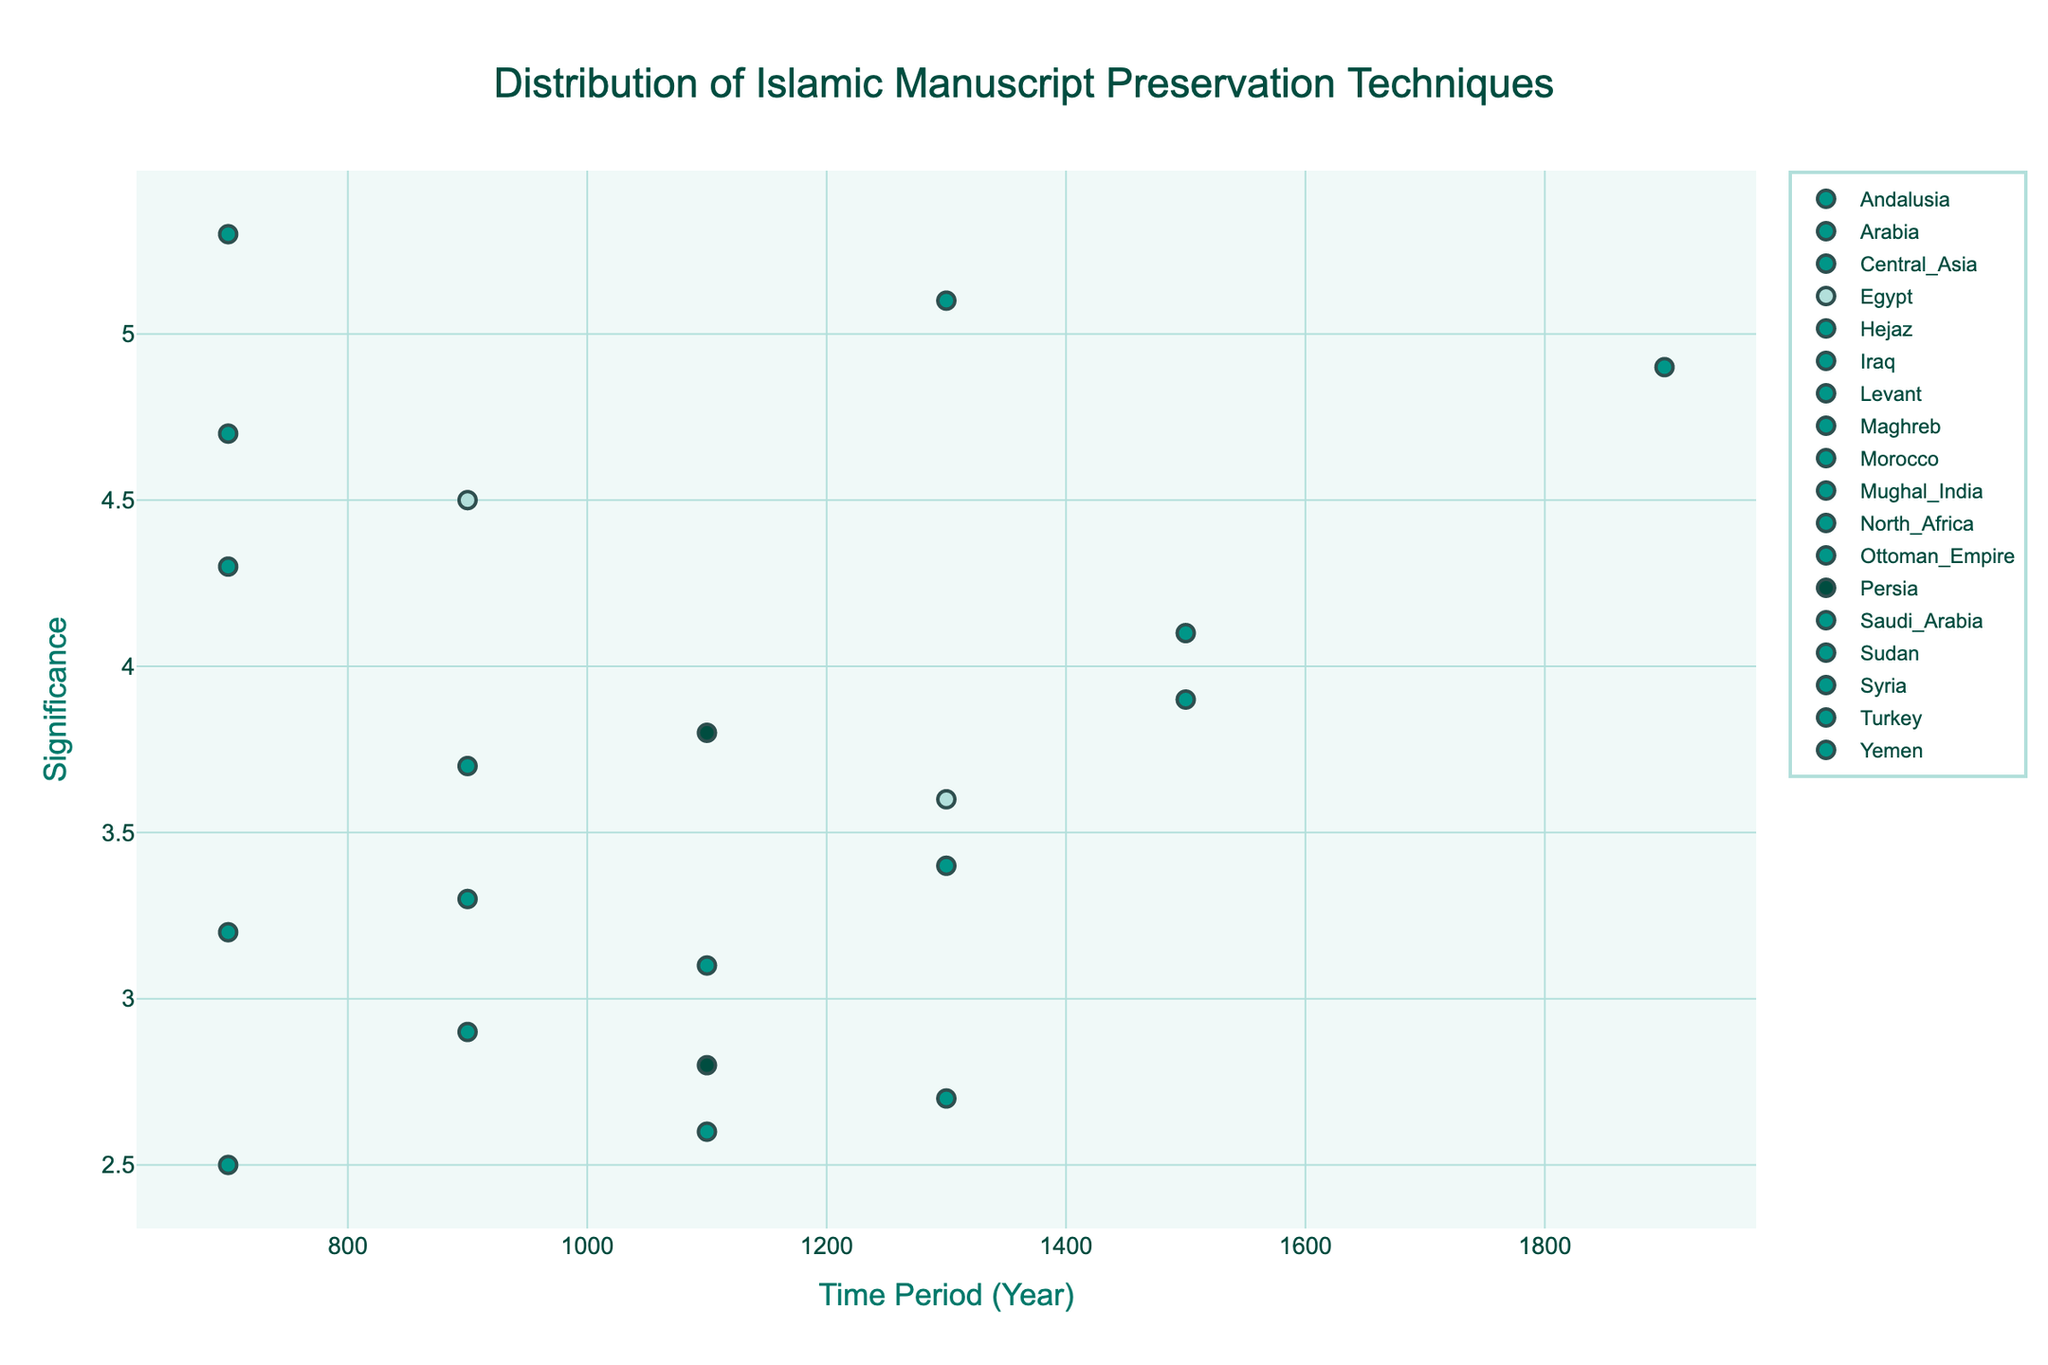What is the title of the plot? The title is prominently displayed at the top of the plot. It reads "Distribution of Islamic Manuscript Preservation Techniques" as indicated in the code.
Answer: Distribution of Islamic Manuscript Preservation Techniques What are the X and Y axes representing? The X-axis shows the "Time Period (Year)," indicating different eras from 700 to 2100, and the Y-axis shows "Significance," representing the significance level of the preservation technique. Both axes titles are specifically set in the code.
Answer: Time Period (Year), Significance How many regions are included in the plot? The plot includes different regions, each with its own markers. By counting the unique regions using the code, there are 15 regions represented.
Answer: 15 Which technique has the highest significance, and what is its value? By observing the highest point on the Y-axis, we can see that "Quranic Illumination" in Hejaz during 700-900 has the highest significance with a value of 5.3.
Answer: Quranic Illumination, 5.3 What is the significance of "Manuscript Digitization" in Saudi Arabia during the 1900-2100 period? By locating the data point for "Manuscript Digitization" in Saudi Arabia at the 1900-2100 period on the X-axis, we find its significance value at 4.9.
Answer: 4.9 Compare the significance of "Leather Binding" in the Maghreb region and "Paper Preservation" in Egypt. Which one is higher, and by how much? Check the significance values for both techniques: "Leather Binding" in Maghreb has a significance of 3.2, and "Paper Preservation" in Egypt has a significance of 4.5. Therefore, 4.5 - 3.2 gives a difference of 1.3.
Answer: Paper Preservation, 1.3 In which time period and region was the "Vellum Preparation" technique significant, and what was its significance value? By identifying the data point labeled 'Vellum Preparation,' it is significant in North Africa during the 1100-1300 period and has a significance value of 3.1 as per the data.
Answer: 1100-1300, North Africa, 3.1 Which technique has the lowest significance, and during which time period and region did it occur? The lowest point on the Y-axis corresponds to "Papyrus Conservation" in Sudan during the 700-900 period with a significance value of 2.5.
Answer: Papyrus Conservation, 700-900, Sudan What is the average significance value for preservation techniques in the 1100-1300 period? The techniques in the 1100-1300 period have significance values of 2.8, 2.6, 3.1, and 3.8. Calculating the average: (2.8 + 2.6 + 3.1 + 3.8) / 4 = 3.075.
Answer: 3.075 